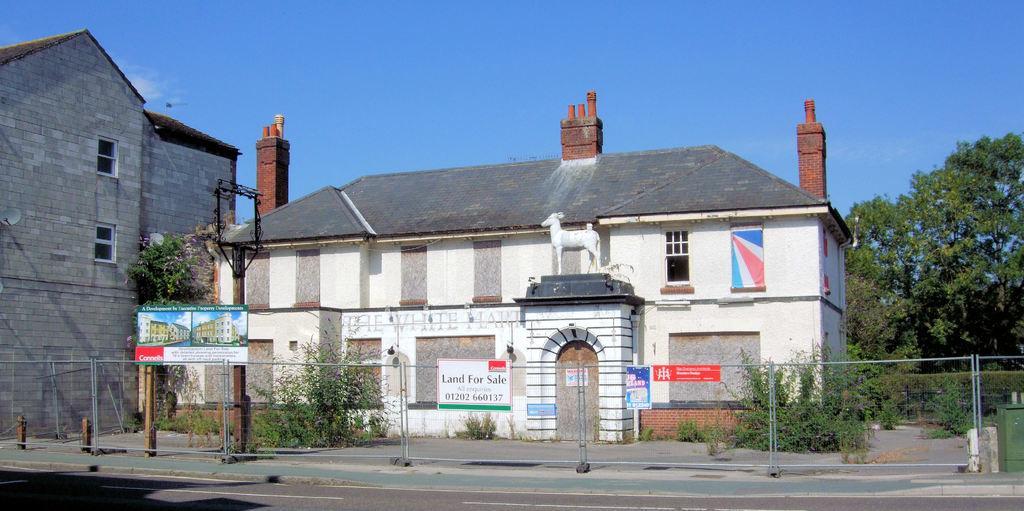Can you describe this image briefly? In this picture I can see fence, plants, there are birds, there are houses, trees, and in the background there is sky. 